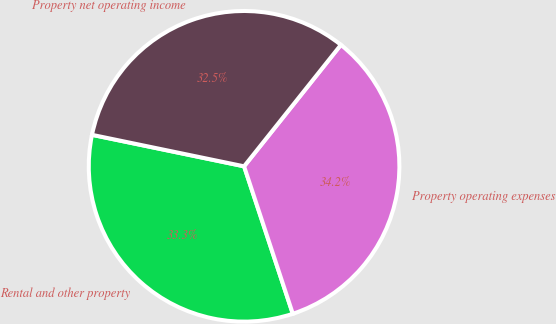Convert chart to OTSL. <chart><loc_0><loc_0><loc_500><loc_500><pie_chart><fcel>Rental and other property<fcel>Property operating expenses<fcel>Property net operating income<nl><fcel>33.33%<fcel>34.21%<fcel>32.46%<nl></chart> 